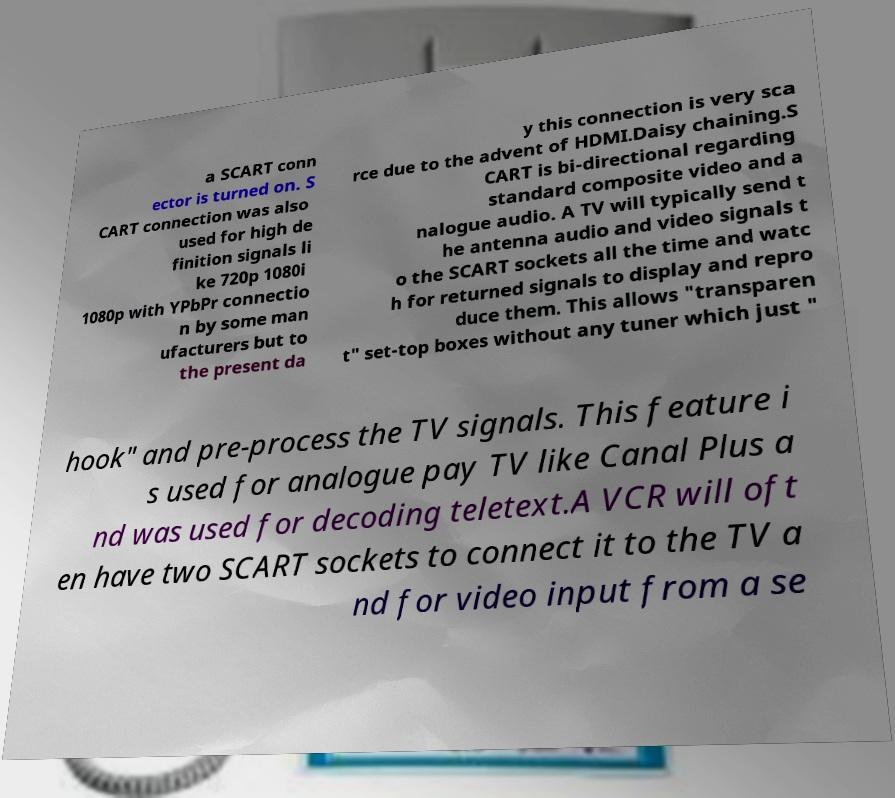Could you extract and type out the text from this image? a SCART conn ector is turned on. S CART connection was also used for high de finition signals li ke 720p 1080i 1080p with YPbPr connectio n by some man ufacturers but to the present da y this connection is very sca rce due to the advent of HDMI.Daisy chaining.S CART is bi-directional regarding standard composite video and a nalogue audio. A TV will typically send t he antenna audio and video signals t o the SCART sockets all the time and watc h for returned signals to display and repro duce them. This allows "transparen t" set-top boxes without any tuner which just " hook" and pre-process the TV signals. This feature i s used for analogue pay TV like Canal Plus a nd was used for decoding teletext.A VCR will oft en have two SCART sockets to connect it to the TV a nd for video input from a se 